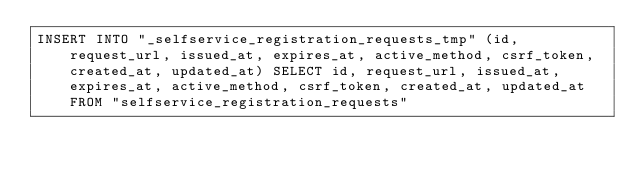<code> <loc_0><loc_0><loc_500><loc_500><_SQL_>INSERT INTO "_selfservice_registration_requests_tmp" (id, request_url, issued_at, expires_at, active_method, csrf_token, created_at, updated_at) SELECT id, request_url, issued_at, expires_at, active_method, csrf_token, created_at, updated_at FROM "selfservice_registration_requests"</code> 